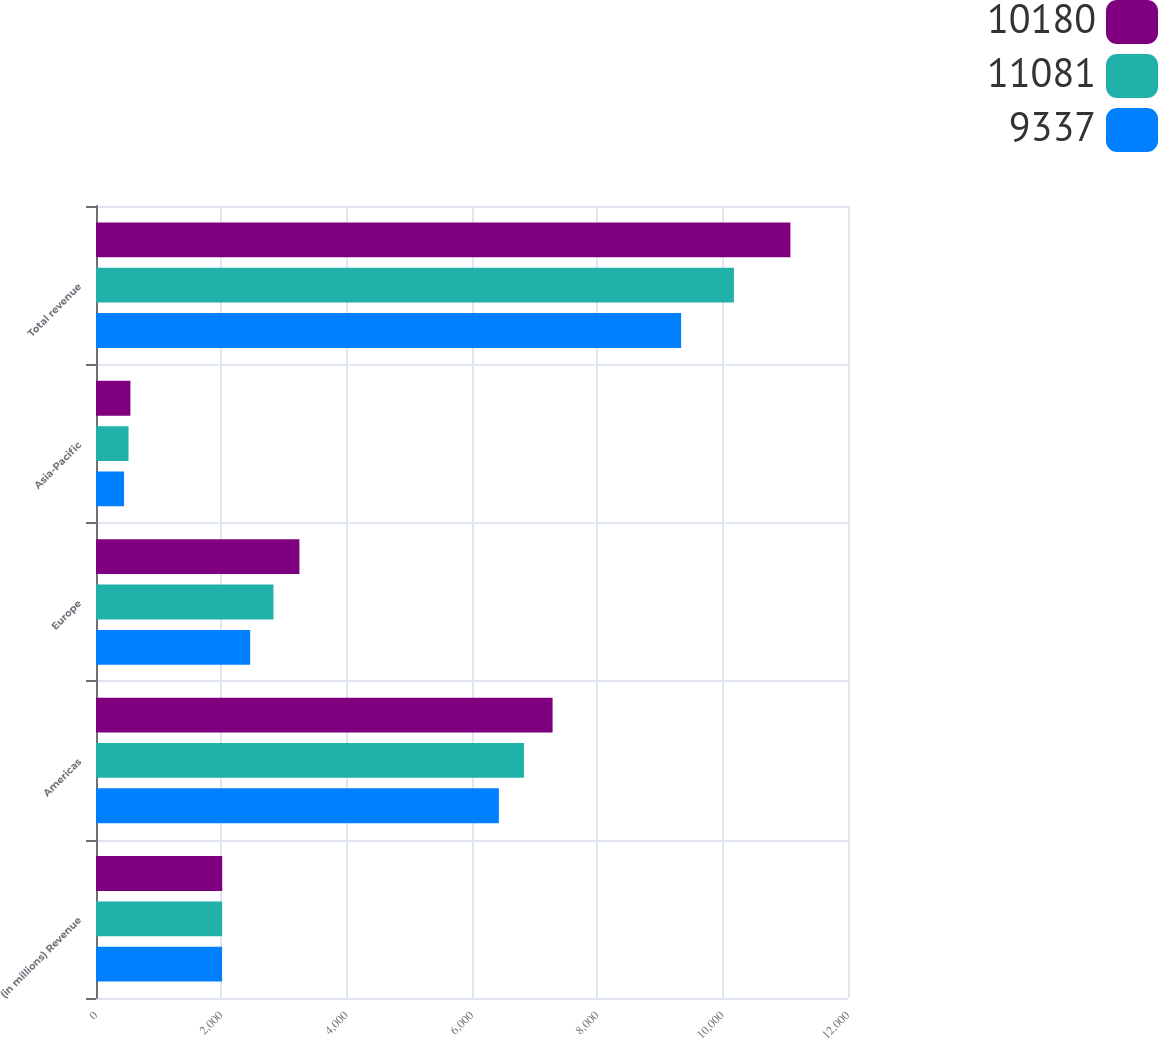Convert chart to OTSL. <chart><loc_0><loc_0><loc_500><loc_500><stacked_bar_chart><ecel><fcel>(in millions) Revenue<fcel>Americas<fcel>Europe<fcel>Asia-Pacific<fcel>Total revenue<nl><fcel>10180<fcel>2014<fcel>7286<fcel>3246<fcel>549<fcel>11081<nl><fcel>11081<fcel>2013<fcel>6829<fcel>2832<fcel>519<fcel>10180<nl><fcel>9337<fcel>2012<fcel>6429<fcel>2460<fcel>448<fcel>9337<nl></chart> 